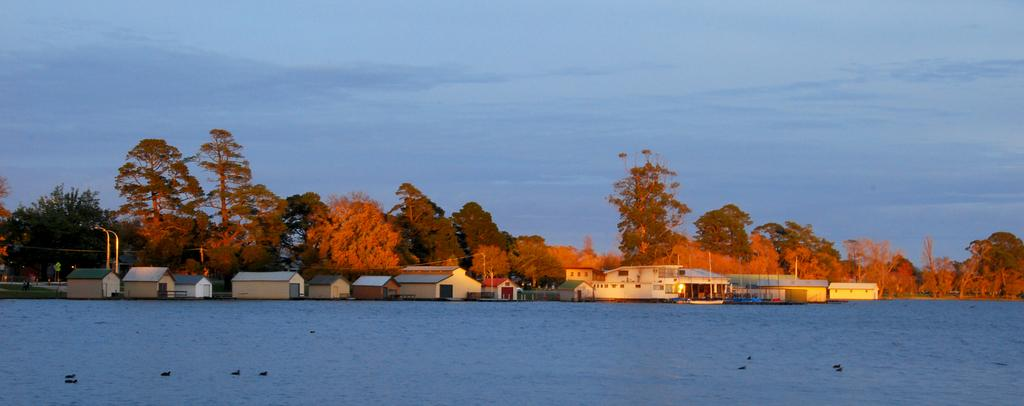What type of structures can be seen in the image? There are houses in the image. What other natural elements are present in the image? There are trees in the image. What man-made objects can be seen in the image? There are poles in the image. Are there any living beings visible in the image? Yes, there are people in the image. What is visible in the background of the image? The sky is visible in the image. What animals can be seen in the image? There are birds in the lake. What type of apparel is the destruction wearing in the image? There is no destruction or apparel present in the image. What level of pain can be observed on the people in the image? There is no indication of pain on the people in the image. 